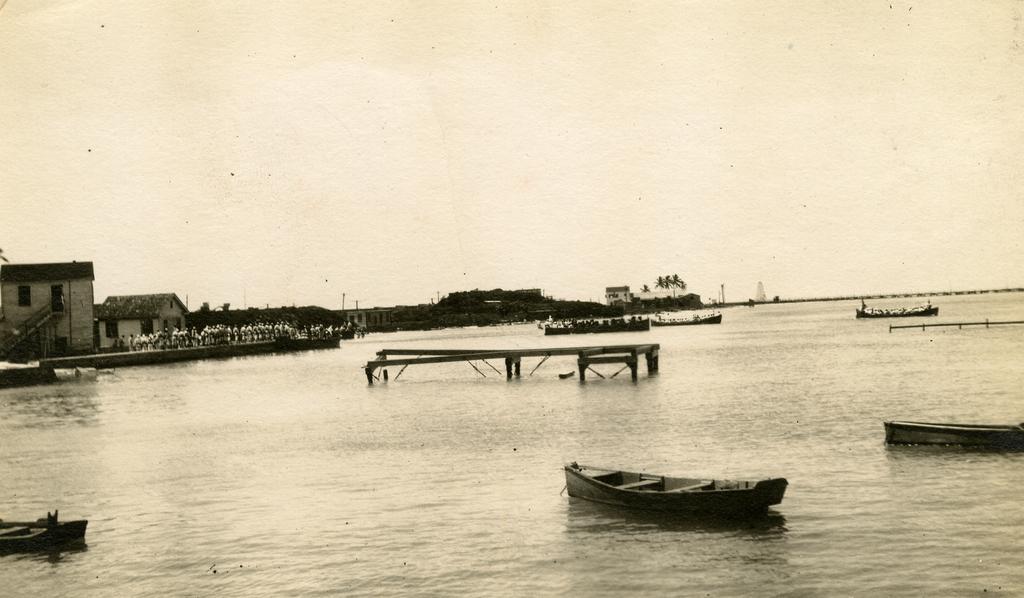Could you give a brief overview of what you see in this image? In the picture I can see the ships sailing on the water. I can see a group of people on the left side. I can see the houses and trees. 